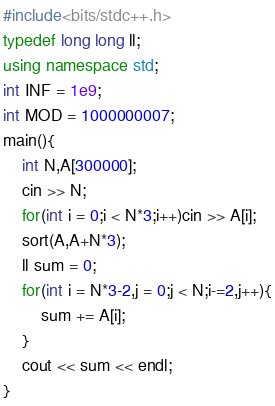Convert code to text. <code><loc_0><loc_0><loc_500><loc_500><_C++_>#include<bits/stdc++.h>
typedef long long ll;
using namespace std;
int INF = 1e9;
int MOD = 1000000007;
main(){
    int N,A[300000];
    cin >> N;
    for(int i = 0;i < N*3;i++)cin >> A[i];
    sort(A,A+N*3);
    ll sum = 0;
    for(int i = N*3-2,j = 0;j < N;i-=2,j++){
        sum += A[i];
    }
    cout << sum << endl;
}</code> 